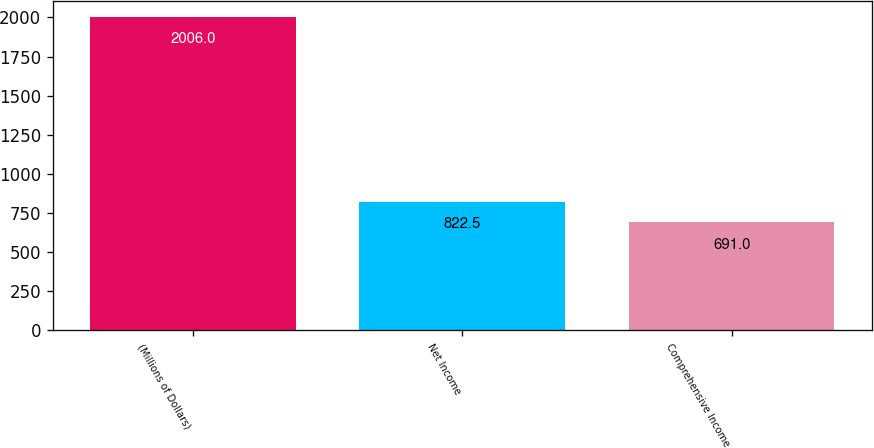<chart> <loc_0><loc_0><loc_500><loc_500><bar_chart><fcel>(Millions of Dollars)<fcel>Net Income<fcel>Comprehensive Income<nl><fcel>2006<fcel>822.5<fcel>691<nl></chart> 